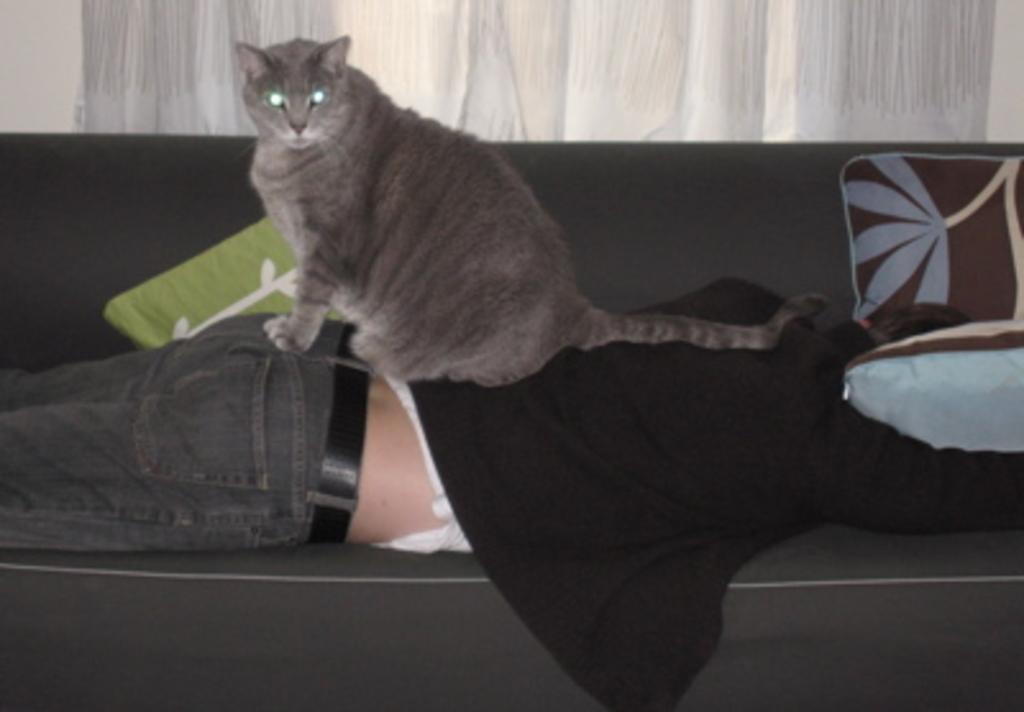Could you give a brief overview of what you see in this image? A man is lying on a sofa. He wears a black color shirt and denim pant. A cat sits on him. There is a window with white color curtain in the background. 